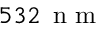<formula> <loc_0><loc_0><loc_500><loc_500>5 3 2 \, n m</formula> 